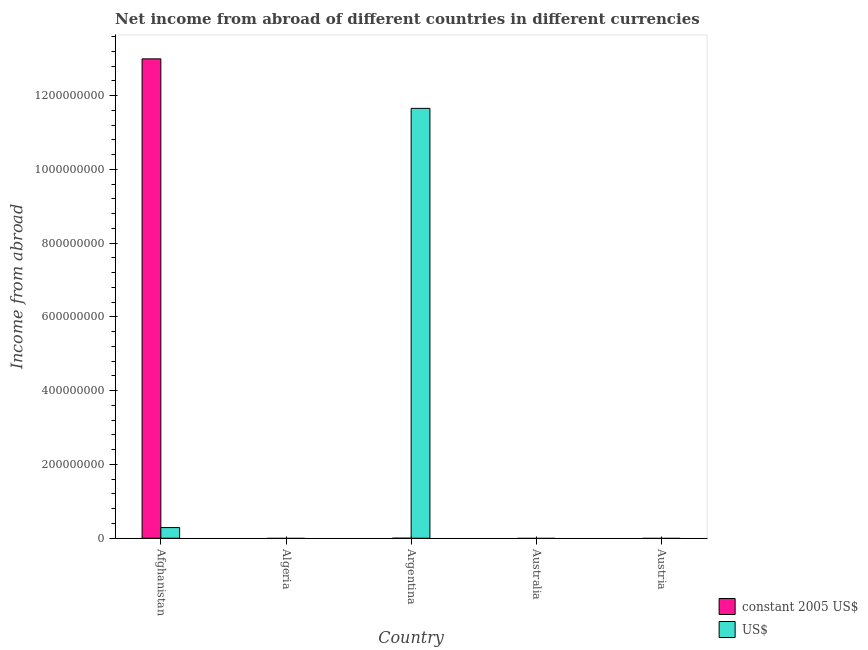Are the number of bars per tick equal to the number of legend labels?
Give a very brief answer. No. How many bars are there on the 5th tick from the right?
Ensure brevity in your answer.  2. What is the label of the 3rd group of bars from the left?
Your answer should be compact. Argentina. What is the income from abroad in us$ in Argentina?
Give a very brief answer. 1.17e+09. Across all countries, what is the maximum income from abroad in constant 2005 us$?
Your answer should be very brief. 1.30e+09. In which country was the income from abroad in us$ maximum?
Provide a succinct answer. Argentina. What is the total income from abroad in us$ in the graph?
Your answer should be compact. 1.19e+09. What is the difference between the income from abroad in constant 2005 us$ in Afghanistan and that in Argentina?
Give a very brief answer. 1.30e+09. What is the average income from abroad in constant 2005 us$ per country?
Your answer should be compact. 2.60e+08. What is the difference between the income from abroad in us$ and income from abroad in constant 2005 us$ in Argentina?
Offer a very short reply. 1.17e+09. Is the income from abroad in us$ in Afghanistan less than that in Argentina?
Make the answer very short. Yes. What is the difference between the highest and the lowest income from abroad in us$?
Your answer should be very brief. 1.17e+09. In how many countries, is the income from abroad in us$ greater than the average income from abroad in us$ taken over all countries?
Keep it short and to the point. 1. How many countries are there in the graph?
Your response must be concise. 5. How are the legend labels stacked?
Your response must be concise. Vertical. What is the title of the graph?
Your answer should be compact. Net income from abroad of different countries in different currencies. Does "Diesel" appear as one of the legend labels in the graph?
Make the answer very short. No. What is the label or title of the Y-axis?
Offer a very short reply. Income from abroad. What is the Income from abroad of constant 2005 US$ in Afghanistan?
Provide a succinct answer. 1.30e+09. What is the Income from abroad of US$ in Afghanistan?
Keep it short and to the point. 2.89e+07. What is the Income from abroad of constant 2005 US$ in Algeria?
Your answer should be very brief. 0. What is the Income from abroad in constant 2005 US$ in Argentina?
Your answer should be very brief. 0.02. What is the Income from abroad of US$ in Argentina?
Offer a terse response. 1.17e+09. What is the Income from abroad in US$ in Australia?
Give a very brief answer. 0. What is the Income from abroad of constant 2005 US$ in Austria?
Ensure brevity in your answer.  0. Across all countries, what is the maximum Income from abroad in constant 2005 US$?
Your answer should be very brief. 1.30e+09. Across all countries, what is the maximum Income from abroad in US$?
Provide a short and direct response. 1.17e+09. What is the total Income from abroad of constant 2005 US$ in the graph?
Offer a very short reply. 1.30e+09. What is the total Income from abroad of US$ in the graph?
Make the answer very short. 1.19e+09. What is the difference between the Income from abroad of constant 2005 US$ in Afghanistan and that in Argentina?
Make the answer very short. 1.30e+09. What is the difference between the Income from abroad of US$ in Afghanistan and that in Argentina?
Your answer should be compact. -1.14e+09. What is the difference between the Income from abroad of constant 2005 US$ in Afghanistan and the Income from abroad of US$ in Argentina?
Keep it short and to the point. 1.34e+08. What is the average Income from abroad in constant 2005 US$ per country?
Provide a short and direct response. 2.60e+08. What is the average Income from abroad in US$ per country?
Your answer should be very brief. 2.39e+08. What is the difference between the Income from abroad of constant 2005 US$ and Income from abroad of US$ in Afghanistan?
Ensure brevity in your answer.  1.27e+09. What is the difference between the Income from abroad of constant 2005 US$ and Income from abroad of US$ in Argentina?
Provide a short and direct response. -1.17e+09. What is the ratio of the Income from abroad of constant 2005 US$ in Afghanistan to that in Argentina?
Your response must be concise. 5.31e+1. What is the ratio of the Income from abroad of US$ in Afghanistan to that in Argentina?
Provide a succinct answer. 0.02. What is the difference between the highest and the lowest Income from abroad of constant 2005 US$?
Keep it short and to the point. 1.30e+09. What is the difference between the highest and the lowest Income from abroad of US$?
Ensure brevity in your answer.  1.17e+09. 